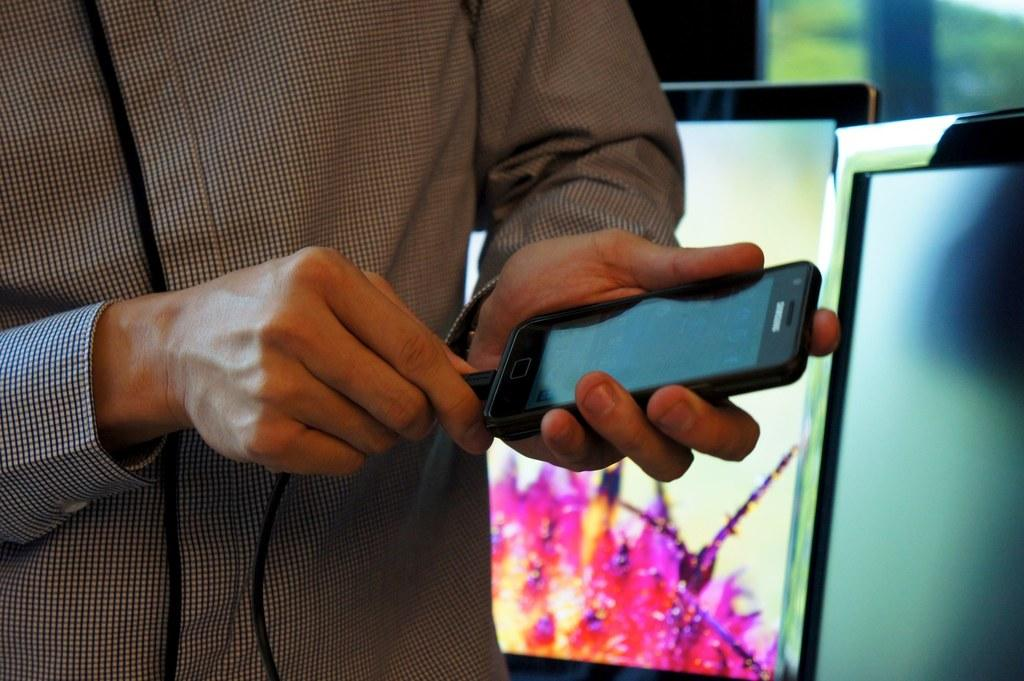Who is present in the image? There is a man in the image. What is the man wearing? The man is wearing a checked shirt. What is the man holding in one hand? The man is holding a charger in one hand. What is the man holding in the other hand? The man is holding a mobile phone in the other hand. What can be seen in the background of the image? There are two monitors and a glass window in the background of the image. What type of wire is the man using to act in the image? There is no wire present in the image, and the man is not acting; he is simply holding a charger and a mobile phone. 